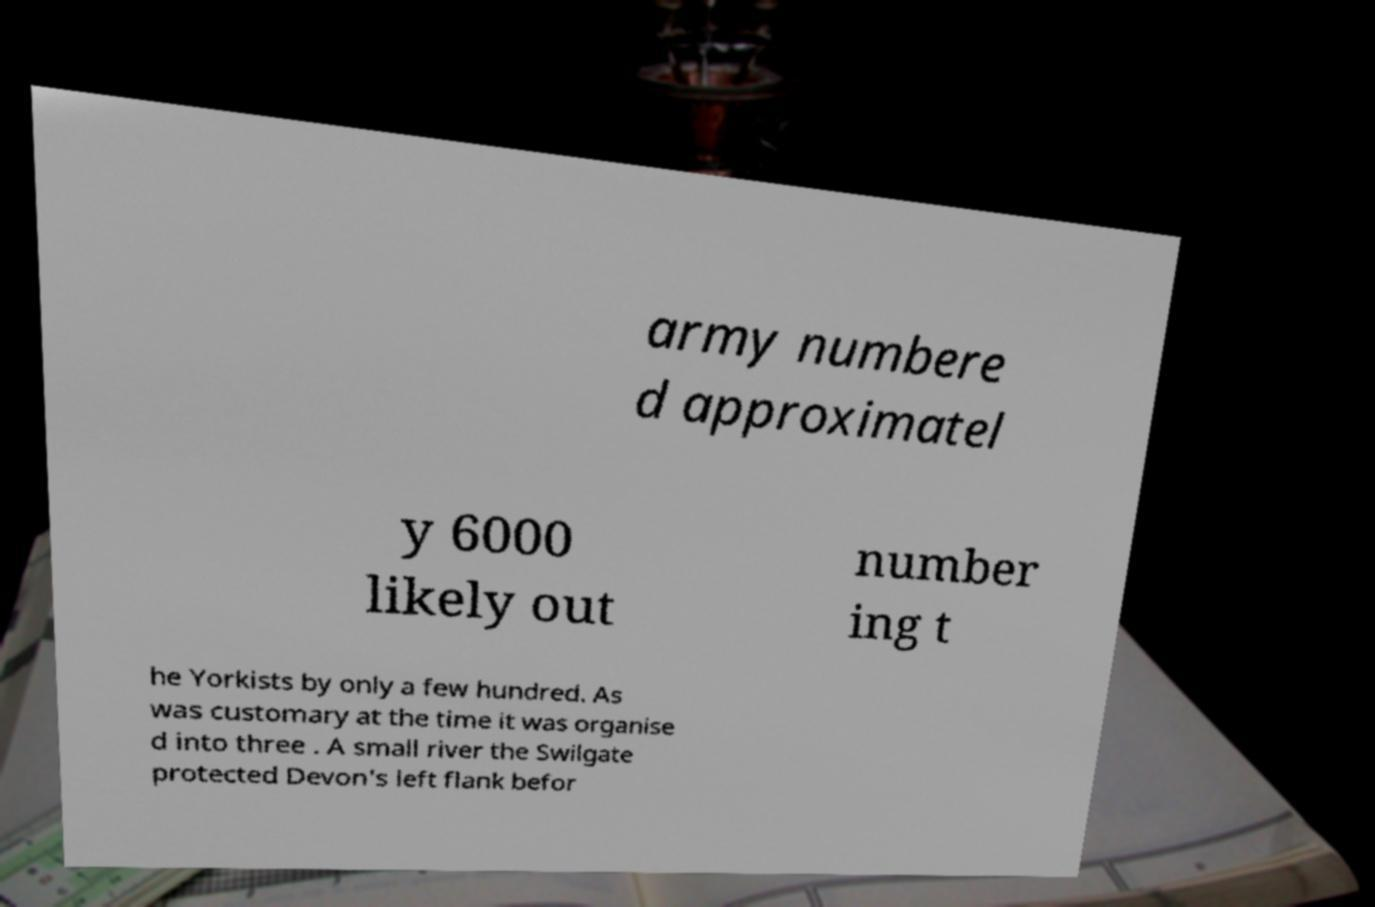For documentation purposes, I need the text within this image transcribed. Could you provide that? army numbere d approximatel y 6000 likely out number ing t he Yorkists by only a few hundred. As was customary at the time it was organise d into three . A small river the Swilgate protected Devon's left flank befor 